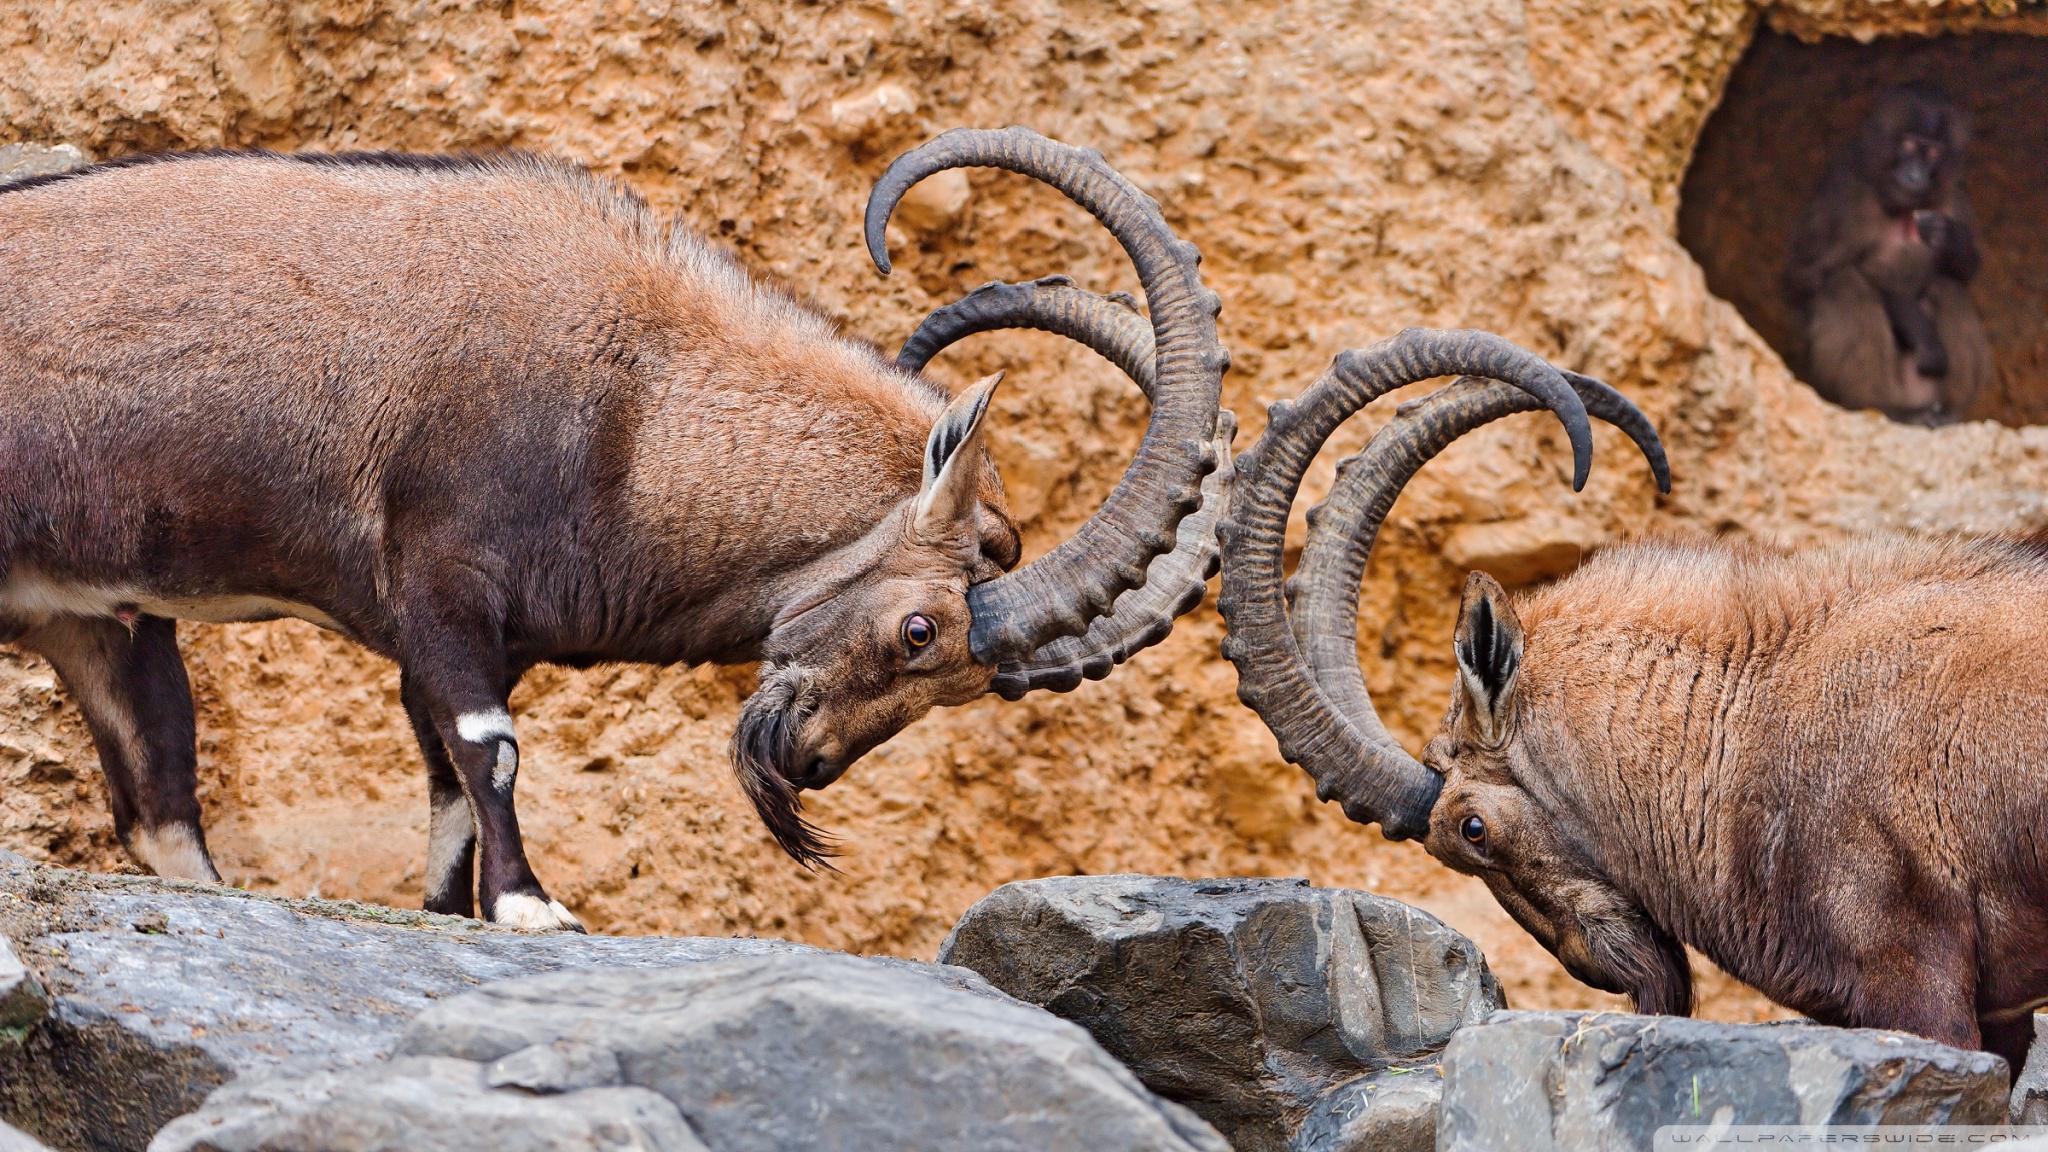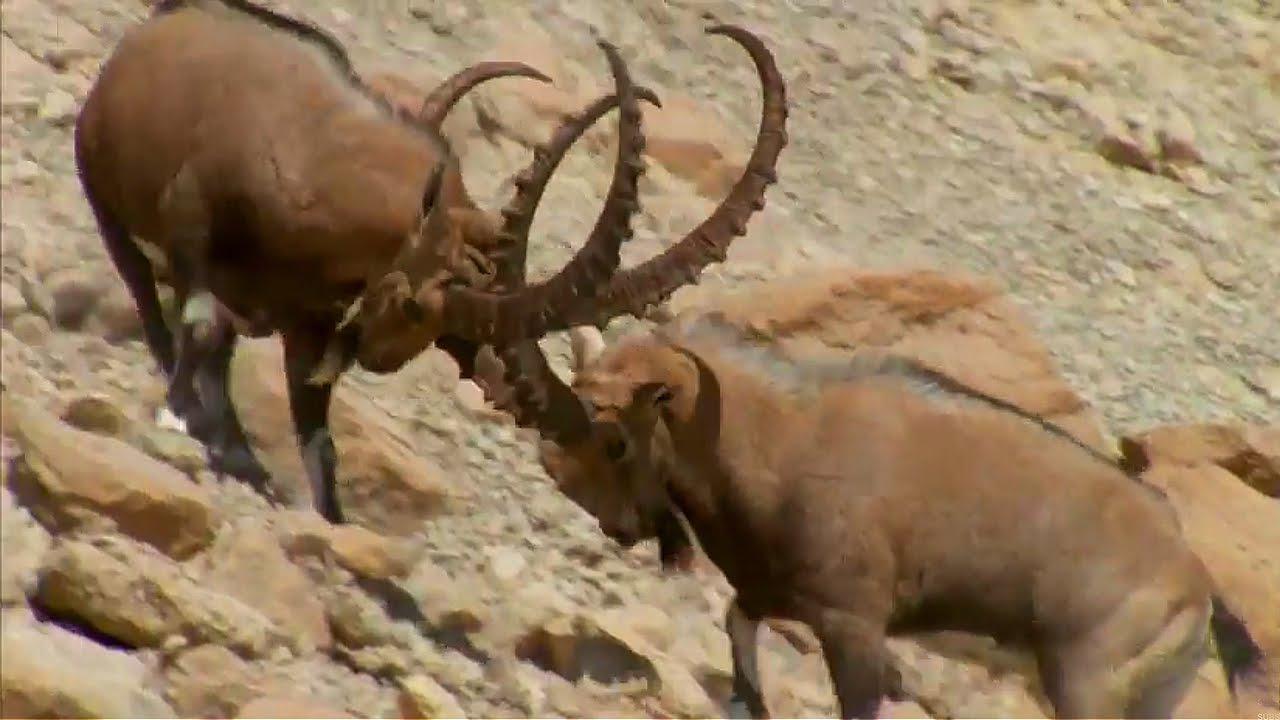The first image is the image on the left, the second image is the image on the right. Evaluate the accuracy of this statement regarding the images: "An image includes a rearing horned animal, with both its front legs high off the ground.". Is it true? Answer yes or no. No. The first image is the image on the left, the second image is the image on the right. Evaluate the accuracy of this statement regarding the images: "Two animals are butting heads in the image on the right.". Is it true? Answer yes or no. Yes. 